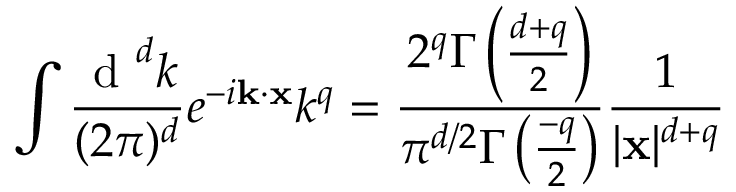<formula> <loc_0><loc_0><loc_500><loc_500>\int \frac { d ^ { d } k } { ( 2 \pi ) ^ { d } } e ^ { - i { k } \cdot { x } } k ^ { q } = \frac { 2 ^ { q } \Gamma \left ( \frac { d + q } { 2 } \right ) } { \pi ^ { d / 2 } \Gamma \left ( \frac { - q } { 2 } \right ) } \frac { 1 } { | { x } | ^ { d + q } }</formula> 